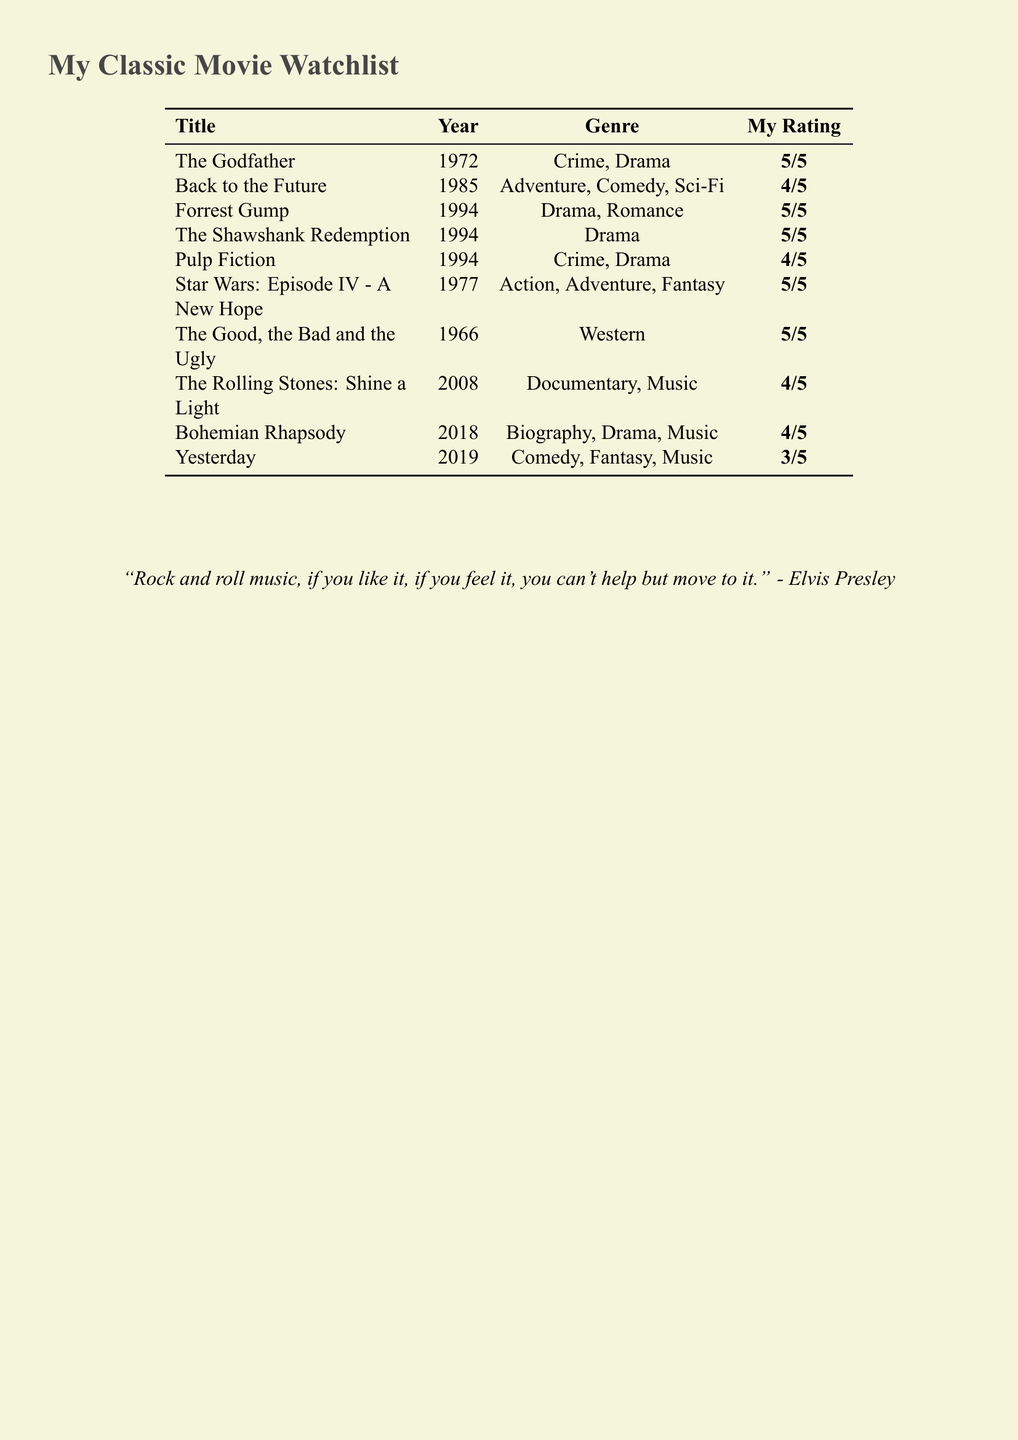What is the title of the movie released in 1972? The movie released in 1972 is "The Godfather."
Answer: The Godfather How many movies in the watchlist have a rating of 5/5? There are five movies with a rating of 5/5 in the watchlist.
Answer: 5 What genre does "Forrest Gump" belong to? "Forrest Gump" is classified as a Drama and Romance.
Answer: Drama, Romance Which movie is a documentary about the Rolling Stones? The documentary about the Rolling Stones is titled "The Rolling Stones: Shine a Light."
Answer: The Rolling Stones: Shine a Light In what year was "Bohemian Rhapsody" released? "Bohemian Rhapsody" was released in 2018.
Answer: 2018 What is the average rating of the movies in the watchlist? The average rating is calculated based on the given ratings: (5 + 4 + 5 + 5 + 4 + 5 + 5 + 4 + 4 + 3) / 10 = 4.4.
Answer: 4.4 How many genres are listed for the movie "Back to the Future"? "Back to the Future" has three genres listed: Adventure, Comedy, and Sci-Fi.
Answer: 3 Which movie from the list is the oldest? The oldest movie in the list is "The Good, the Bad and the Ugly," released in 1966.
Answer: The Good, the Bad and the Ugly What is the only movie listed with a rating of 3/5? The only movie with a rating of 3/5 is "Yesterday."
Answer: Yesterday 